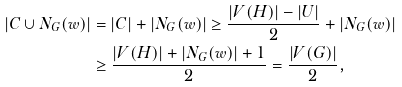Convert formula to latex. <formula><loc_0><loc_0><loc_500><loc_500>| C \cup N _ { G } ( w ) | & = | C | + | N _ { G } ( w ) | \geq \frac { | V ( H ) | - | U | } { 2 } + | N _ { G } ( w ) | \\ & \geq \frac { | V ( H ) | + | N _ { G } ( w ) | + 1 } { 2 } = \frac { | V ( G ) | } { 2 } ,</formula> 